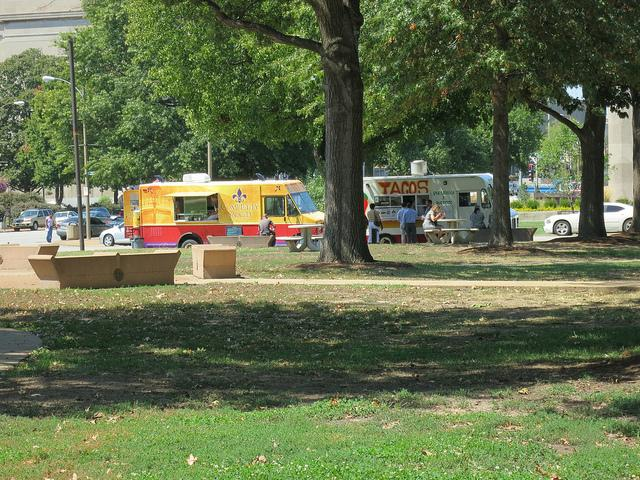What is the yellow truck doing? selling food 